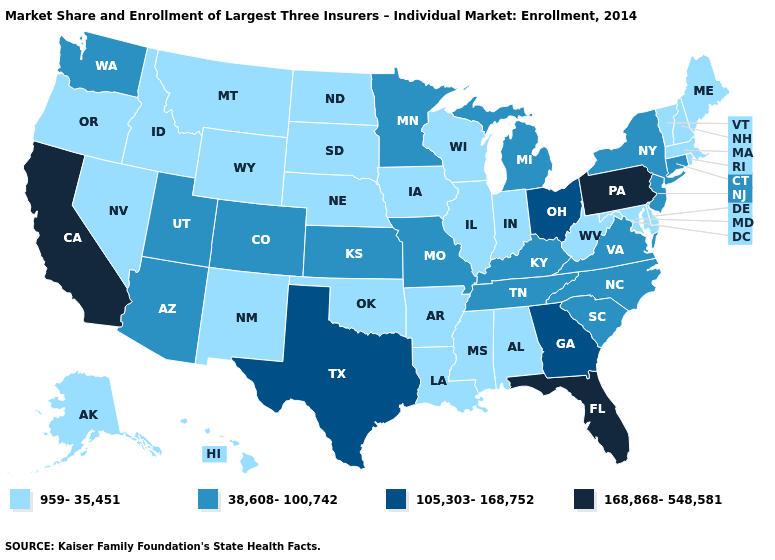Which states have the highest value in the USA?
Write a very short answer. California, Florida, Pennsylvania. Does Arkansas have a lower value than Connecticut?
Be succinct. Yes. Does the first symbol in the legend represent the smallest category?
Answer briefly. Yes. Which states have the highest value in the USA?
Be succinct. California, Florida, Pennsylvania. Does the first symbol in the legend represent the smallest category?
Short answer required. Yes. Among the states that border Wisconsin , does Michigan have the highest value?
Give a very brief answer. Yes. Among the states that border West Virginia , which have the lowest value?
Keep it brief. Maryland. What is the value of Mississippi?
Concise answer only. 959-35,451. Among the states that border South Dakota , which have the highest value?
Write a very short answer. Minnesota. Does Virginia have the same value as Washington?
Answer briefly. Yes. What is the lowest value in the USA?
Keep it brief. 959-35,451. Which states have the highest value in the USA?
Quick response, please. California, Florida, Pennsylvania. Which states have the lowest value in the USA?
Give a very brief answer. Alabama, Alaska, Arkansas, Delaware, Hawaii, Idaho, Illinois, Indiana, Iowa, Louisiana, Maine, Maryland, Massachusetts, Mississippi, Montana, Nebraska, Nevada, New Hampshire, New Mexico, North Dakota, Oklahoma, Oregon, Rhode Island, South Dakota, Vermont, West Virginia, Wisconsin, Wyoming. Which states have the highest value in the USA?
Be succinct. California, Florida, Pennsylvania. What is the value of Alaska?
Write a very short answer. 959-35,451. 